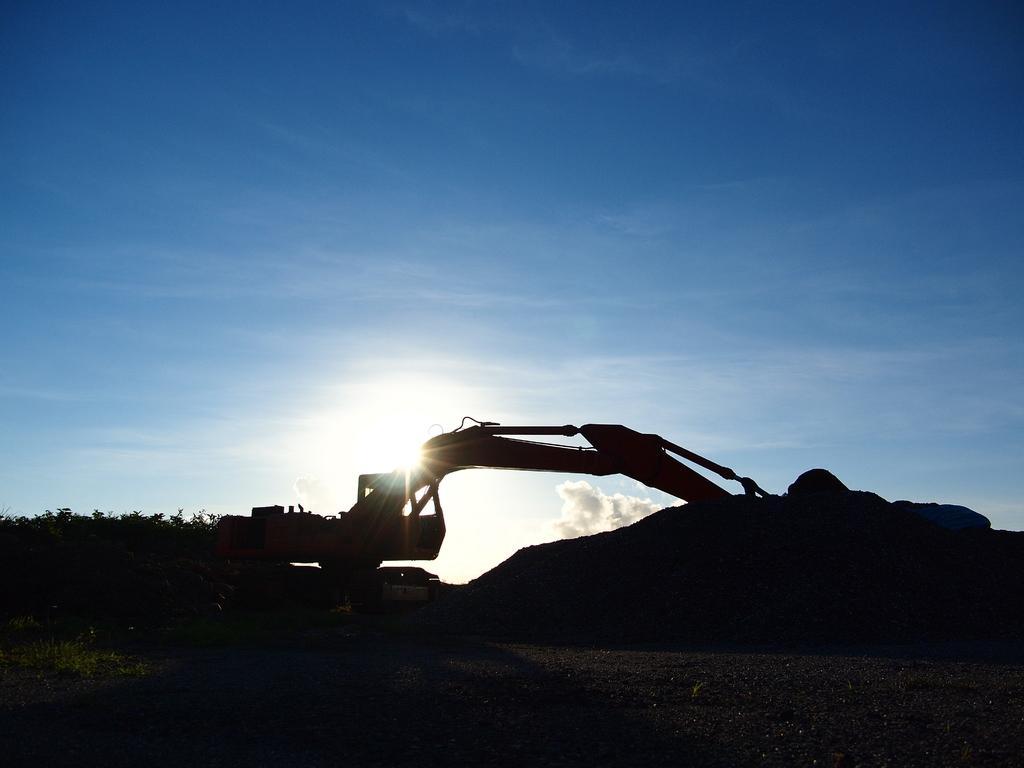Describe this image in one or two sentences. In the foreground of the picture there are trees, soil and a machinery. Sky is sunny. 